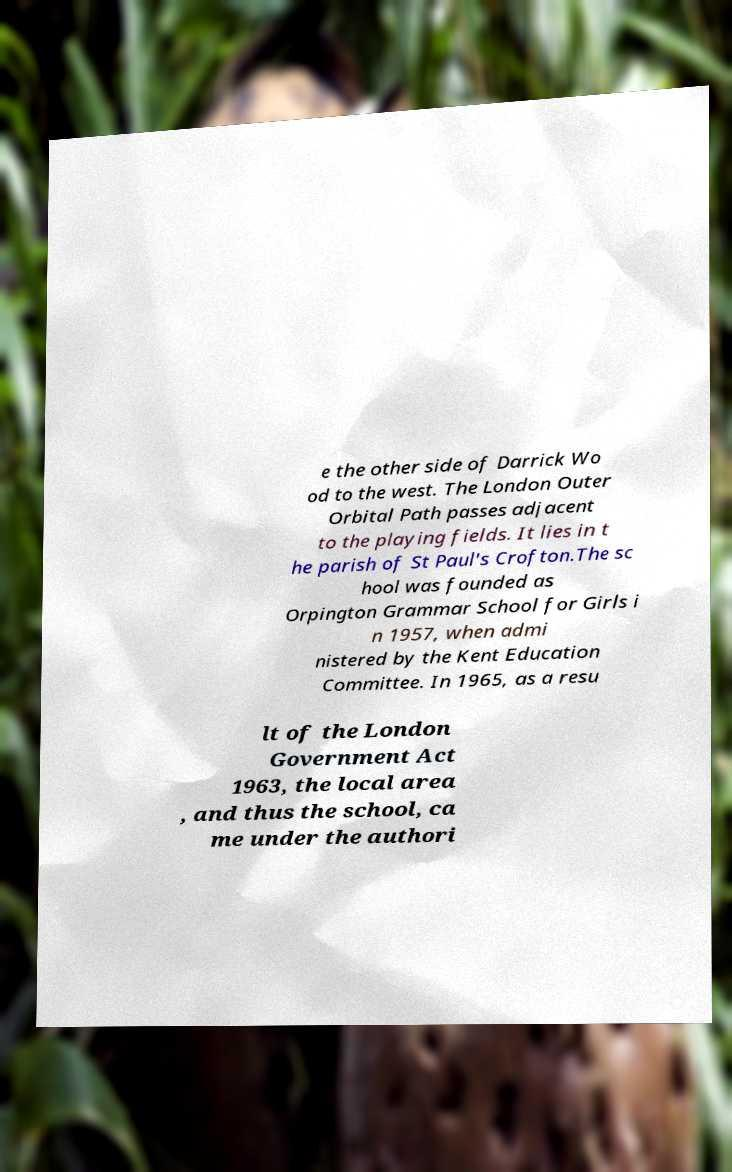There's text embedded in this image that I need extracted. Can you transcribe it verbatim? e the other side of Darrick Wo od to the west. The London Outer Orbital Path passes adjacent to the playing fields. It lies in t he parish of St Paul's Crofton.The sc hool was founded as Orpington Grammar School for Girls i n 1957, when admi nistered by the Kent Education Committee. In 1965, as a resu lt of the London Government Act 1963, the local area , and thus the school, ca me under the authori 